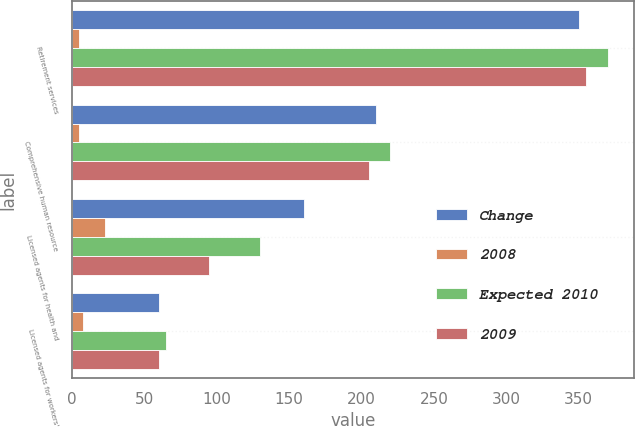Convert chart. <chart><loc_0><loc_0><loc_500><loc_500><stacked_bar_chart><ecel><fcel>Retirement services<fcel>Comprehensive human resource<fcel>Licensed agents for health and<fcel>Licensed agents for workers'<nl><fcel>Change<fcel>350<fcel>210<fcel>160<fcel>60<nl><fcel>2008<fcel>5<fcel>5<fcel>23<fcel>8<nl><fcel>Expected 2010<fcel>370<fcel>220<fcel>130<fcel>65<nl><fcel>2009<fcel>355<fcel>205<fcel>95<fcel>60<nl></chart> 